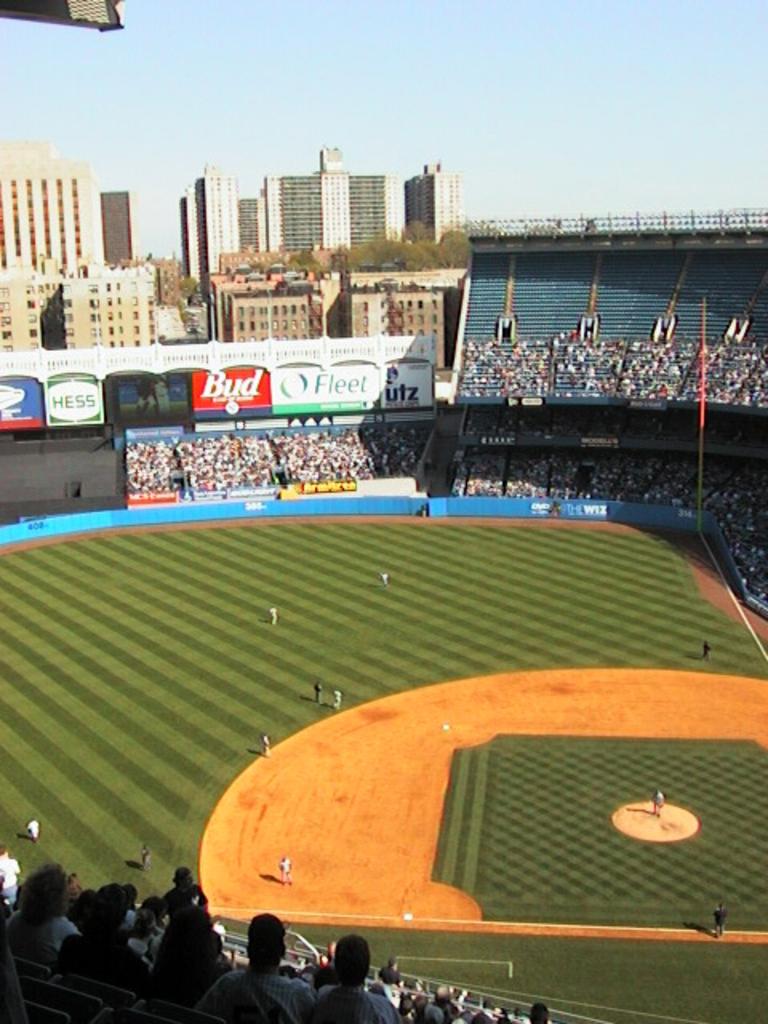What beer company sign can be seen?
Provide a short and direct response. Bud. 